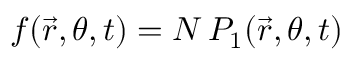<formula> <loc_0><loc_0><loc_500><loc_500>f ( \vec { r } , \theta , t ) = N \, P _ { 1 } ( \vec { r } , \theta , t )</formula> 